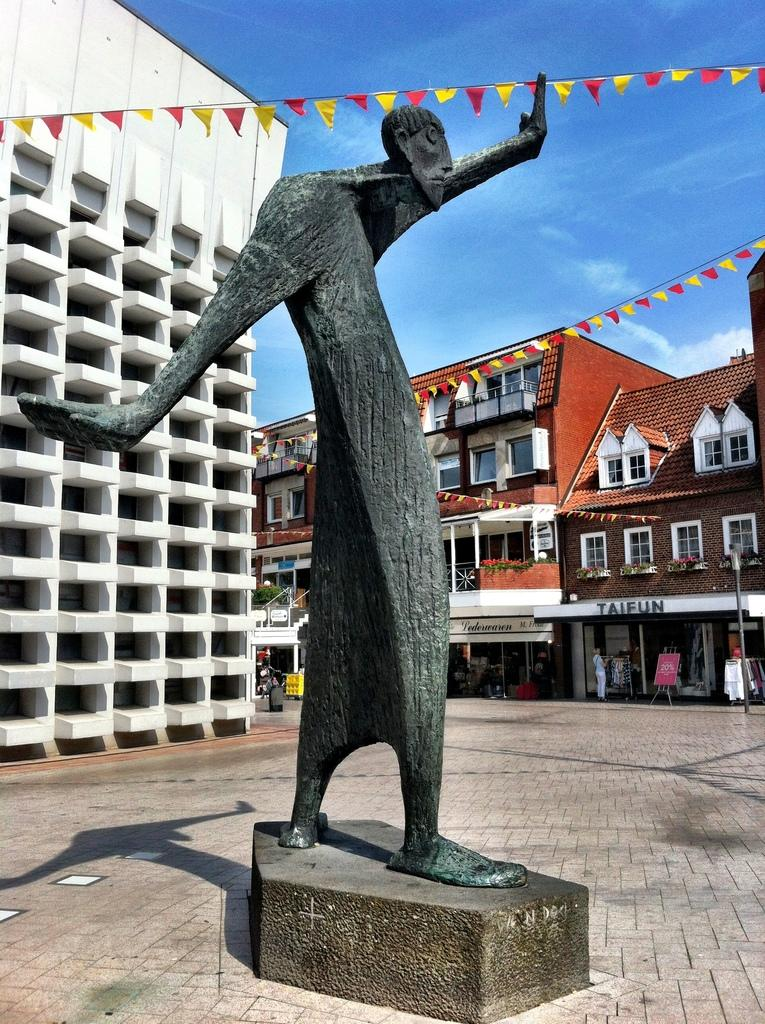What is the main subject in the image? There is a statue in the image. What can be seen in the background of the image? The sky with clouds is visible in the background of the image. What type of structures are present in the image? There are buildings with windows in the image. Are there any symbols or markers in the image? Yes, there are flags in the image. What is the path used for in the image? The path in the image might be used for walking or transportation. Can you describe the person standing in the image? There is a person standing in the image, but their appearance or clothing cannot be determined from the provided facts. What type of wheel is attached to the statue in the image? There is no wheel attached to the statue in the image. What type of authority is represented by the statue in the image? The provided facts do not mention any specific authority or person represented by the statue. 